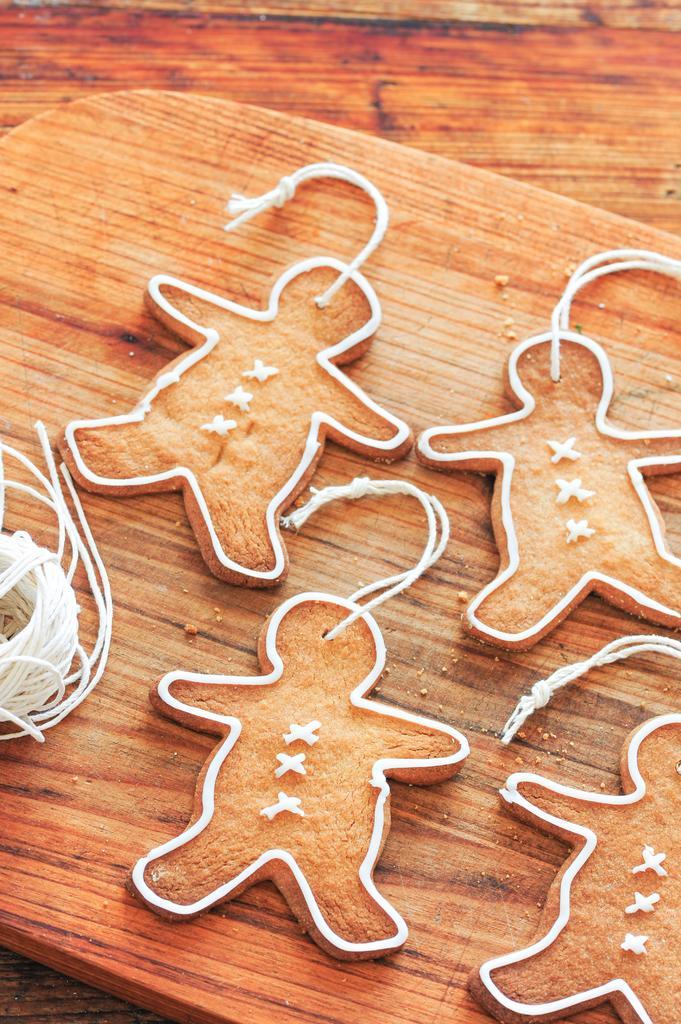In one or two sentences, can you explain what this image depicts? In this image there are a few human shaped cookies placed on top of a board. 